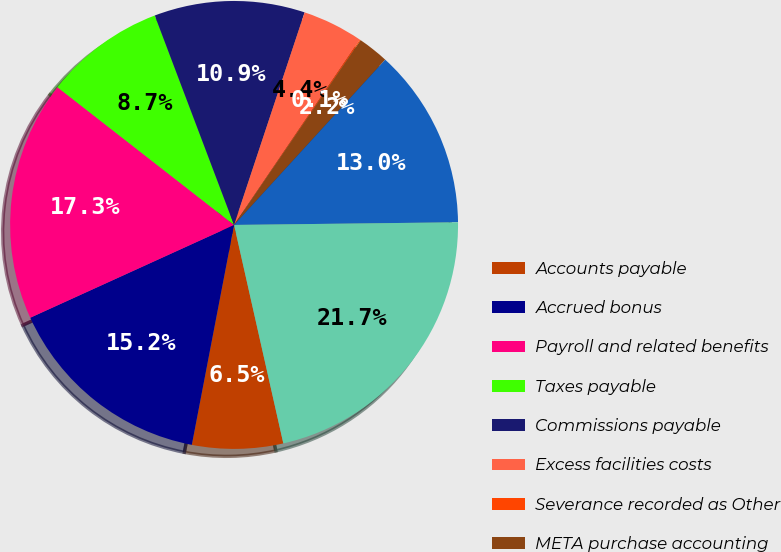<chart> <loc_0><loc_0><loc_500><loc_500><pie_chart><fcel>Accounts payable<fcel>Accrued bonus<fcel>Payroll and related benefits<fcel>Taxes payable<fcel>Commissions payable<fcel>Excess facilities costs<fcel>Severance recorded as Other<fcel>META purchase accounting<fcel>Other accrued liabilities<fcel>Total accounts payable and<nl><fcel>6.55%<fcel>15.18%<fcel>17.34%<fcel>8.7%<fcel>10.86%<fcel>4.39%<fcel>0.07%<fcel>2.23%<fcel>13.02%<fcel>21.66%<nl></chart> 